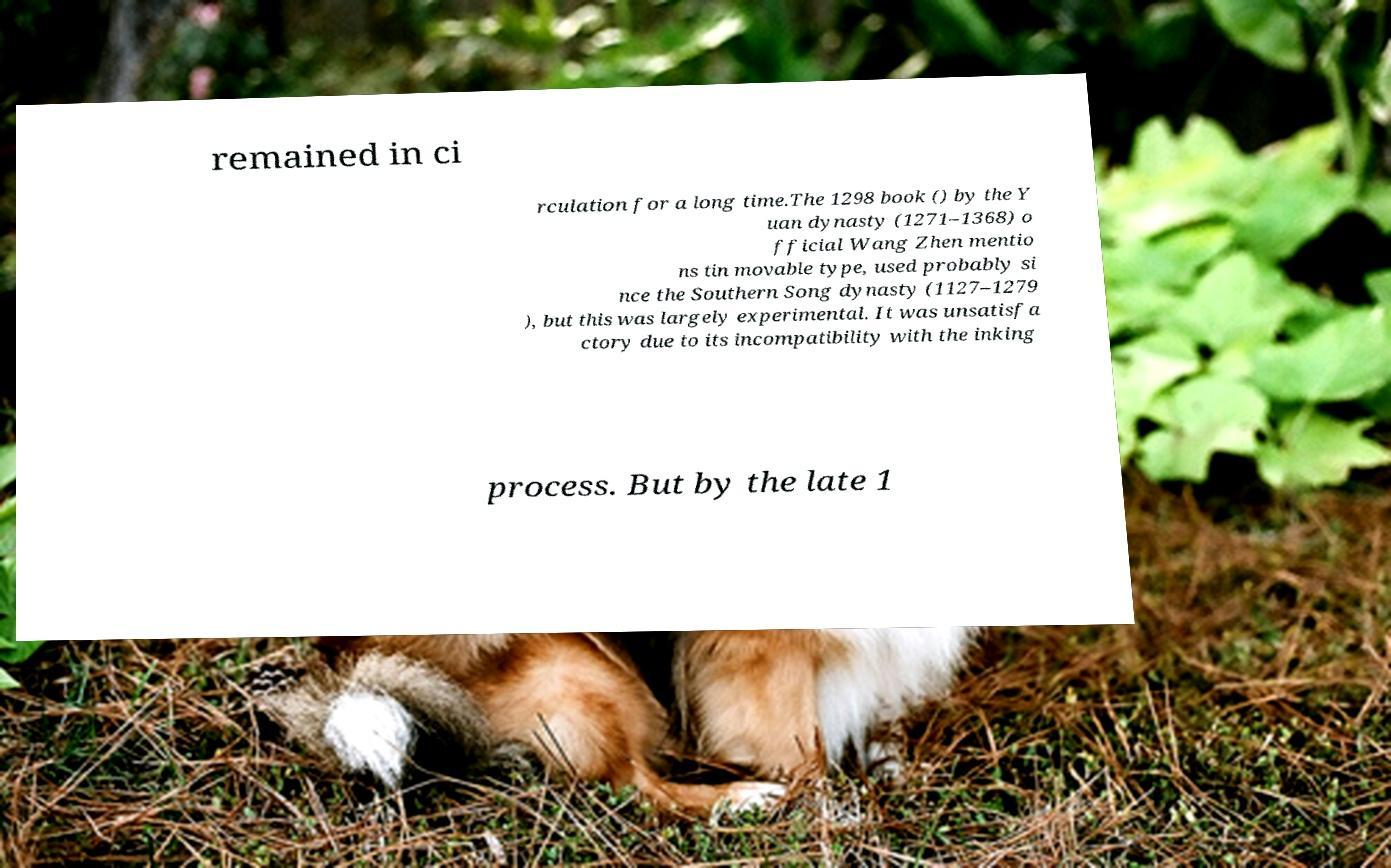What messages or text are displayed in this image? I need them in a readable, typed format. remained in ci rculation for a long time.The 1298 book () by the Y uan dynasty (1271–1368) o fficial Wang Zhen mentio ns tin movable type, used probably si nce the Southern Song dynasty (1127–1279 ), but this was largely experimental. It was unsatisfa ctory due to its incompatibility with the inking process. But by the late 1 